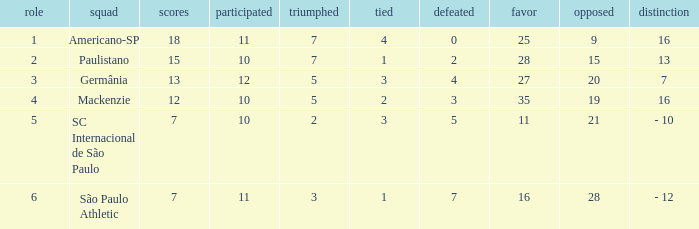Name the most for when difference is 7 27.0. 